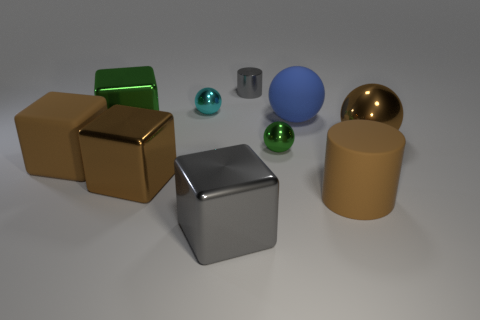Subtract 1 spheres. How many spheres are left? 3 Subtract all gray cylinders. Subtract all gray spheres. How many cylinders are left? 1 Subtract all spheres. How many objects are left? 6 Add 2 big green things. How many big green things are left? 3 Add 1 large brown matte things. How many large brown matte things exist? 3 Subtract 1 brown cylinders. How many objects are left? 9 Subtract all big brown cubes. Subtract all brown rubber objects. How many objects are left? 6 